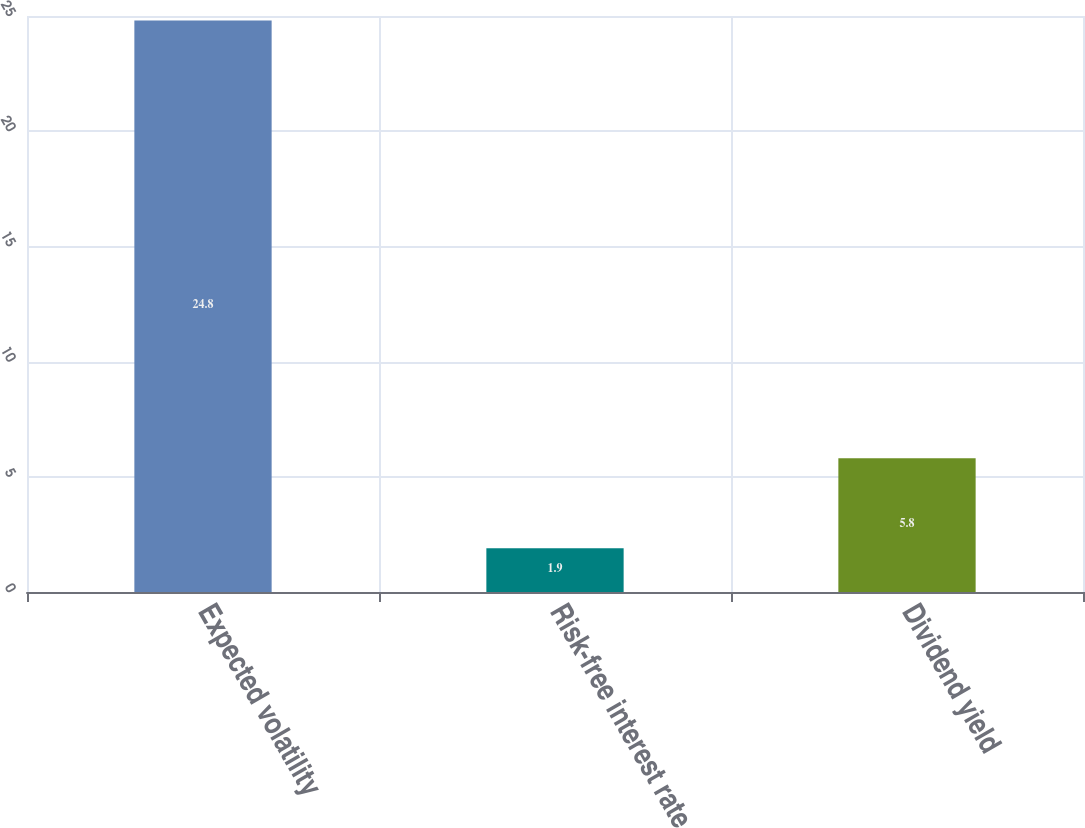<chart> <loc_0><loc_0><loc_500><loc_500><bar_chart><fcel>Expected volatility<fcel>Risk-free interest rate<fcel>Dividend yield<nl><fcel>24.8<fcel>1.9<fcel>5.8<nl></chart> 